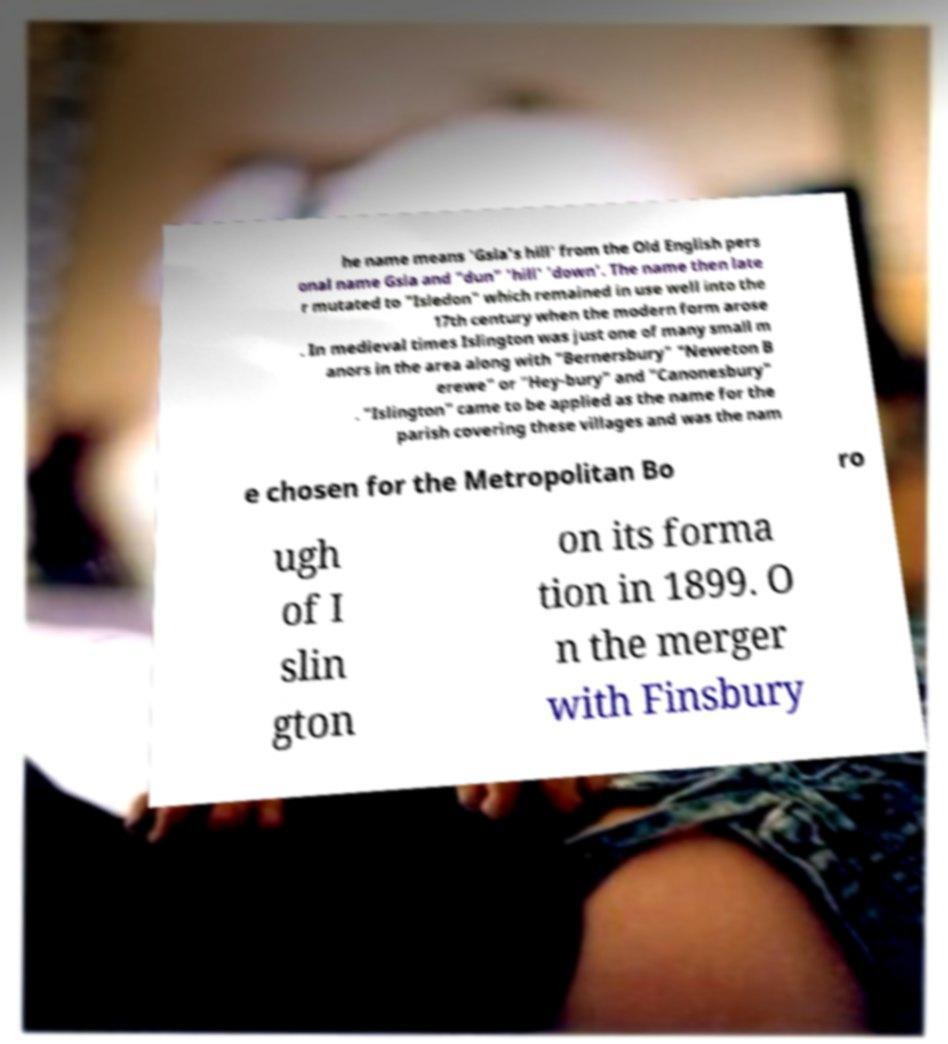Please read and relay the text visible in this image. What does it say? he name means 'Gsla's hill' from the Old English pers onal name Gsla and "dun" 'hill' 'down'. The name then late r mutated to "Isledon" which remained in use well into the 17th century when the modern form arose . In medieval times Islington was just one of many small m anors in the area along with "Bernersbury" "Neweton B erewe" or "Hey-bury" and "Canonesbury" . "Islington" came to be applied as the name for the parish covering these villages and was the nam e chosen for the Metropolitan Bo ro ugh of I slin gton on its forma tion in 1899. O n the merger with Finsbury 